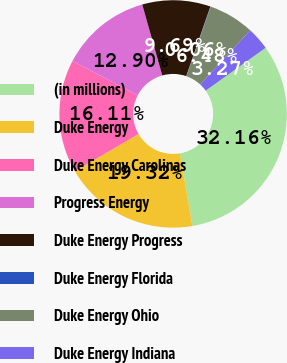Convert chart. <chart><loc_0><loc_0><loc_500><loc_500><pie_chart><fcel>(in millions)<fcel>Duke Energy<fcel>Duke Energy Carolinas<fcel>Progress Energy<fcel>Duke Energy Progress<fcel>Duke Energy Florida<fcel>Duke Energy Ohio<fcel>Duke Energy Indiana<nl><fcel>32.16%<fcel>19.32%<fcel>16.11%<fcel>12.9%<fcel>9.69%<fcel>0.06%<fcel>6.48%<fcel>3.27%<nl></chart> 